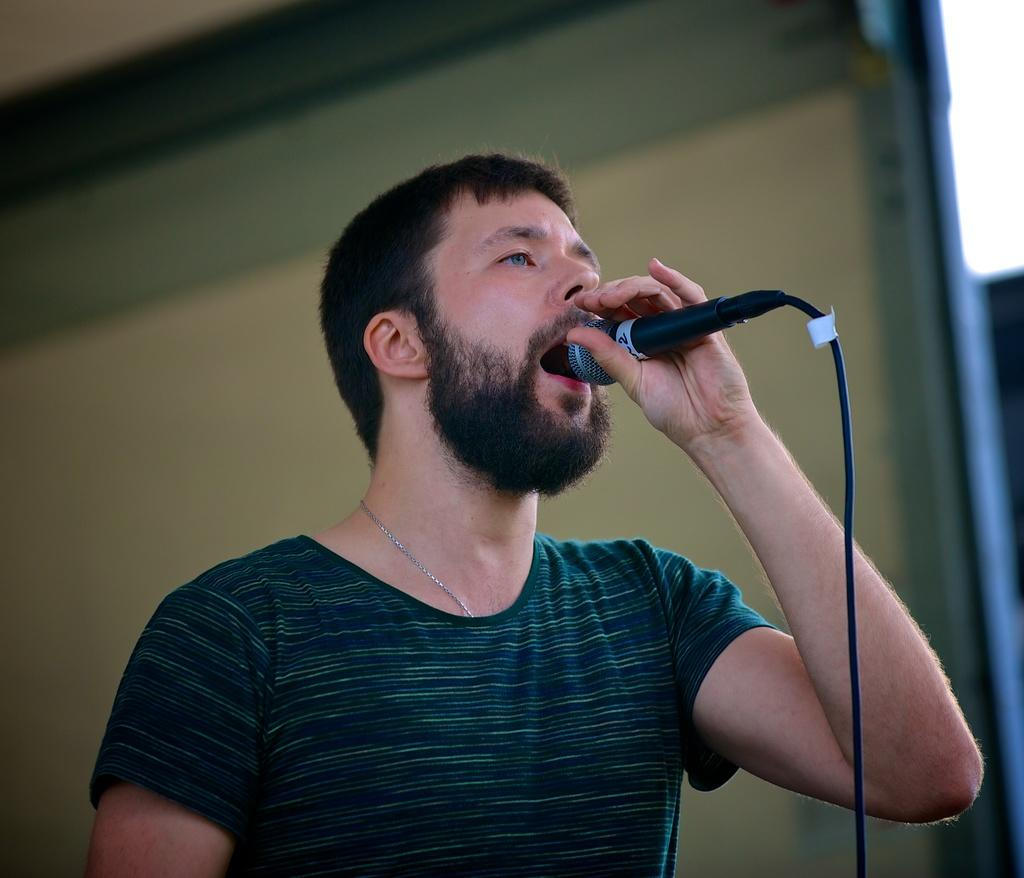What is the main subject of the image? The main subject of the image is a man. What is the man doing in the image? The man is standing and singing in the image. What object is the man holding in the image? The man is holding a microphone in the image. What can be seen in the background of the image? There appears to be a screen in the background of the image. What type of stew is being served at the event in the image? There is no event or stew present in the image; it features a man singing while holding a microphone. Can you tell me how many people are skating in the image? There are no people skating in the image; the man is standing and singing. 